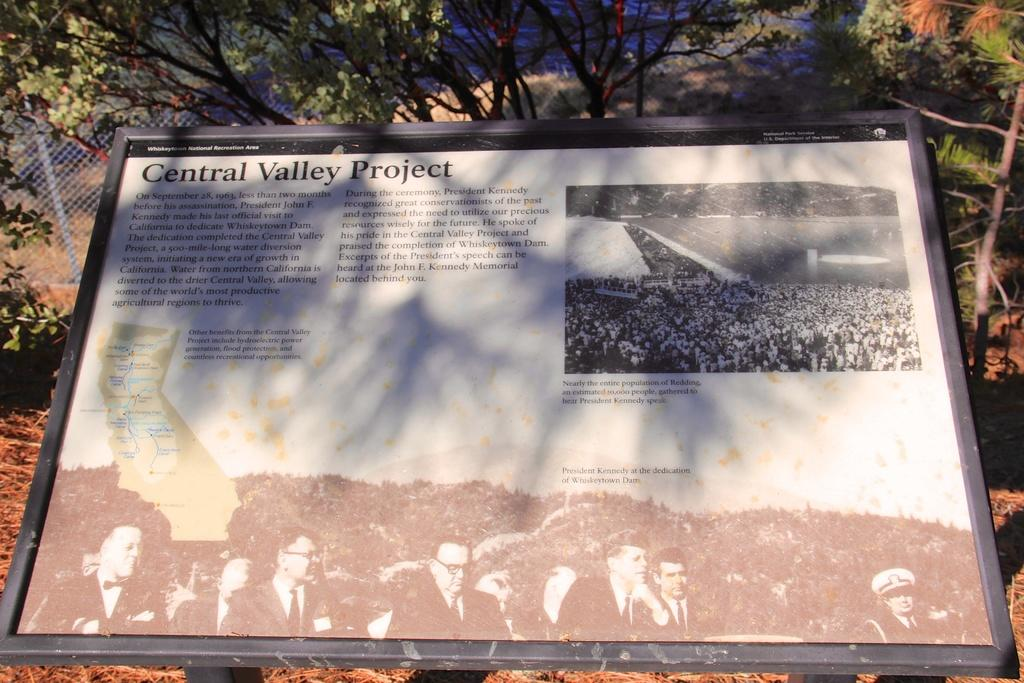What is the main object in the image? There is a board in the image. What type of natural elements can be seen in the image? There are trees in the image. What type of structure is present in the image? There is fencing in the image. Where is the throne located in the image? There is no throne present in the image. What is the mind made of in the image? There is no mention of a mind in the image. 